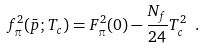<formula> <loc_0><loc_0><loc_500><loc_500>f _ { \pi } ^ { 2 } ( \bar { p } ; T _ { c } ) = F _ { \pi } ^ { 2 } ( 0 ) - \frac { N _ { f } } { 2 4 } T _ { c } ^ { 2 } \ .</formula> 